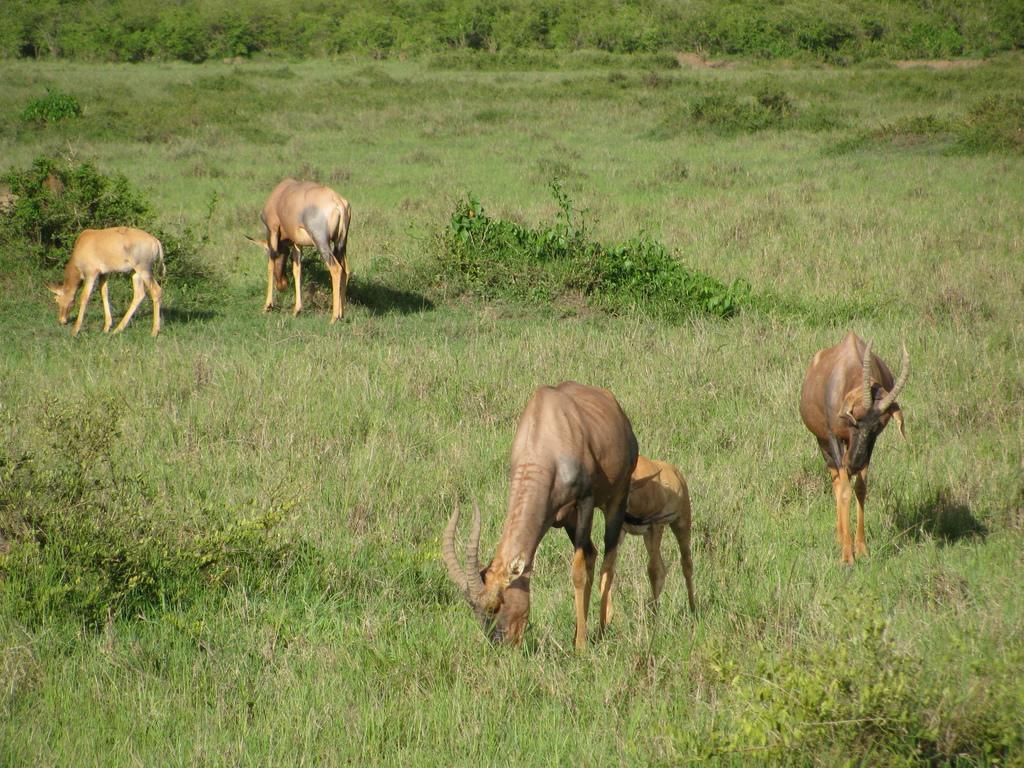How many deer are present in the image? There are five deer in the image. What are the deer doing in the image? The deer are eating green grass. What can be seen in the background of the image? There are plants and trees in the background of the image. How does the deer balance on one leg while eating the grass in the image? The deer are not balancing on one leg in the image; they are standing on all four legs while eating the grass. 